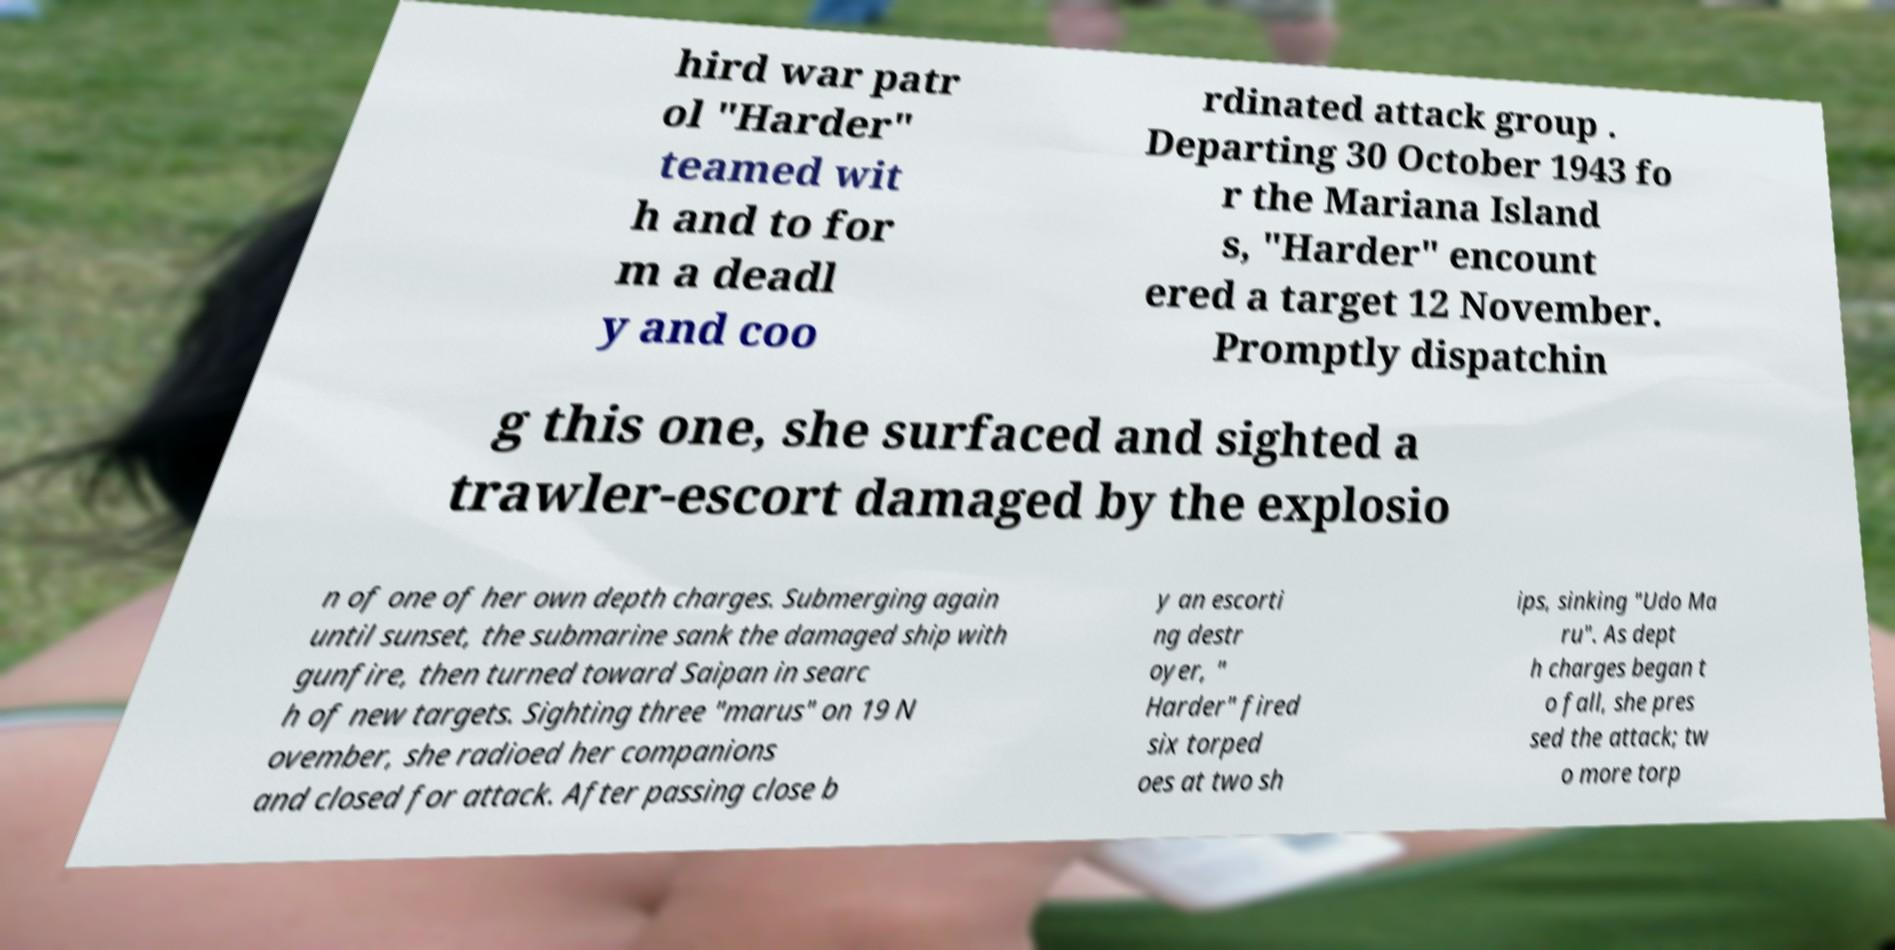Can you read and provide the text displayed in the image?This photo seems to have some interesting text. Can you extract and type it out for me? hird war patr ol "Harder" teamed wit h and to for m a deadl y and coo rdinated attack group . Departing 30 October 1943 fo r the Mariana Island s, "Harder" encount ered a target 12 November. Promptly dispatchin g this one, she surfaced and sighted a trawler-escort damaged by the explosio n of one of her own depth charges. Submerging again until sunset, the submarine sank the damaged ship with gunfire, then turned toward Saipan in searc h of new targets. Sighting three "marus" on 19 N ovember, she radioed her companions and closed for attack. After passing close b y an escorti ng destr oyer, " Harder" fired six torped oes at two sh ips, sinking "Udo Ma ru". As dept h charges began t o fall, she pres sed the attack; tw o more torp 